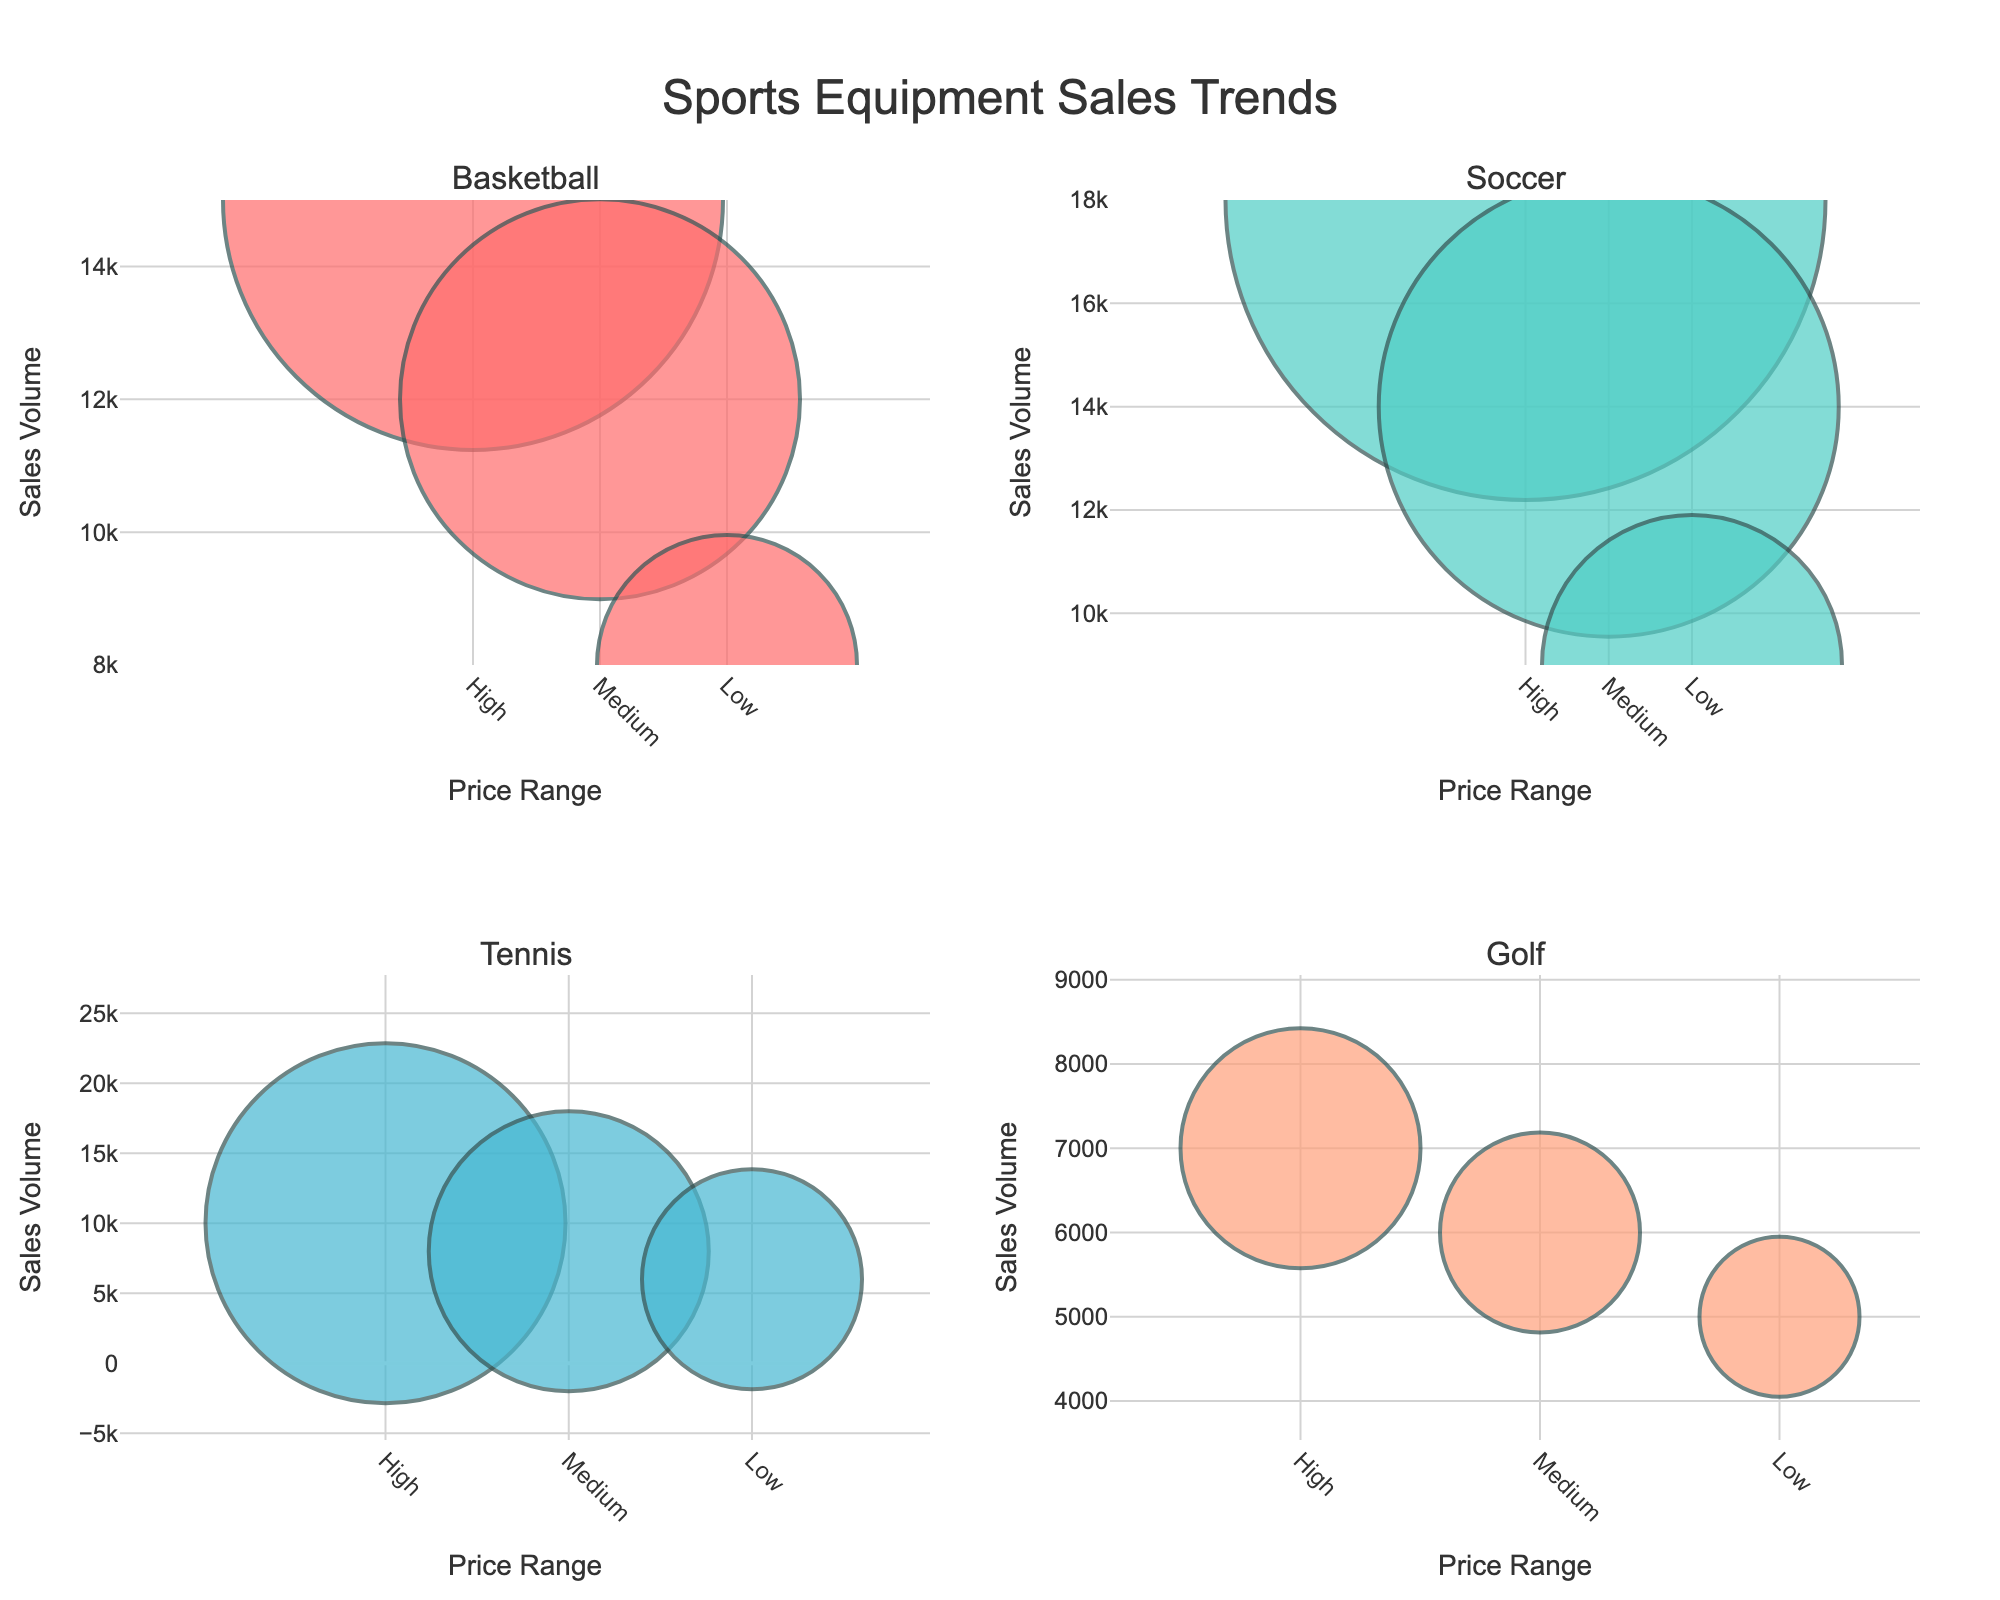How many support characters are listed in the data? Count the number of unique data points in the plot
Answer: 14 Which genre has the highest player satisfaction rating? Observe the point with the highest y-value in the "Player Satisfaction" plots and identify its color, then match to the genre
Answer: Tactical Shooter Are there any support characters with a player satisfaction score below 8? Check the "Player Satisfaction" axis and see if any points are below 8
Answer: Yes (Yuumi) Which support character has the lowest popularity in MOBA games? Find the points in the MOBA genre and locate the lowest value on the "Popularity" axis in the "Popularity" scatterplots
Answer: Yuumi Is there a positive correlation between popularity and player satisfaction? Observe the trend in the scatterplot where "Popularity" is on one axis and "Player Satisfaction" on the other
Answer: Generally, yes Which support character has the highest win rate in an MMORPG game? Identify MMORPG points in the "Win Rate" scatterplots and find the highest value
Answer: White Mage Do tactical shooters generally have higher popularity for their support characters compared to other genres? Observe the position of the tactical shooter point(s) on the "Popularity" axis across slots marked for various genres
Answer: Generally, yes (Sage) Which support character has the closest win rate to 51% among FPS games? Locate FPS points in the "Win Rate" scatterplots and find the one closest to 51%
Answer: Medic 